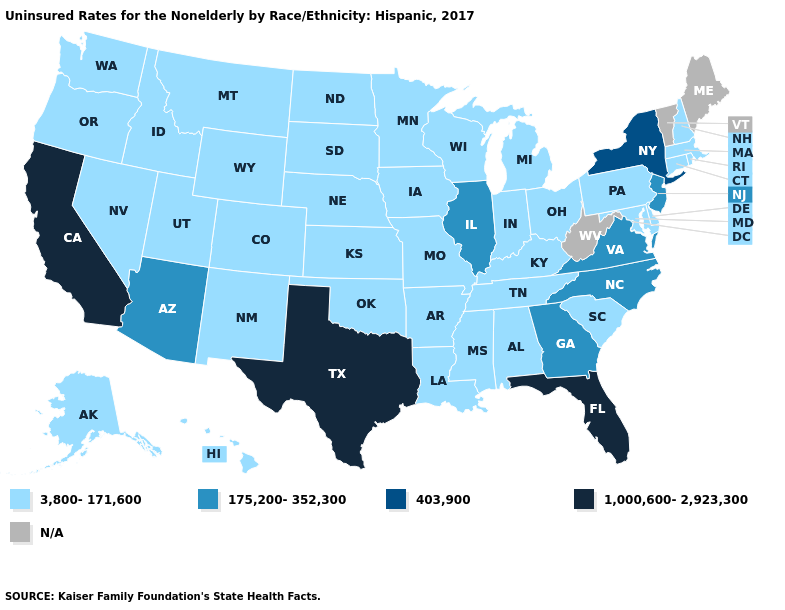How many symbols are there in the legend?
Quick response, please. 5. Name the states that have a value in the range N/A?
Short answer required. Maine, Vermont, West Virginia. Among the states that border Missouri , which have the lowest value?
Short answer required. Arkansas, Iowa, Kansas, Kentucky, Nebraska, Oklahoma, Tennessee. Which states hav the highest value in the West?
Concise answer only. California. Which states hav the highest value in the Northeast?
Keep it brief. New York. Does the map have missing data?
Keep it brief. Yes. What is the lowest value in states that border South Dakota?
Give a very brief answer. 3,800-171,600. What is the lowest value in the MidWest?
Short answer required. 3,800-171,600. Name the states that have a value in the range 175,200-352,300?
Concise answer only. Arizona, Georgia, Illinois, New Jersey, North Carolina, Virginia. Is the legend a continuous bar?
Keep it brief. No. Name the states that have a value in the range 403,900?
Concise answer only. New York. What is the value of Wyoming?
Short answer required. 3,800-171,600. Name the states that have a value in the range 1,000,600-2,923,300?
Be succinct. California, Florida, Texas. Does California have the lowest value in the USA?
Short answer required. No. 